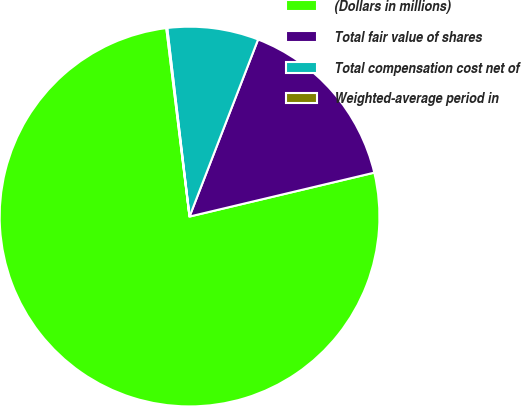Convert chart. <chart><loc_0><loc_0><loc_500><loc_500><pie_chart><fcel>(Dollars in millions)<fcel>Total fair value of shares<fcel>Total compensation cost net of<fcel>Weighted-average period in<nl><fcel>76.76%<fcel>15.41%<fcel>7.75%<fcel>0.08%<nl></chart> 